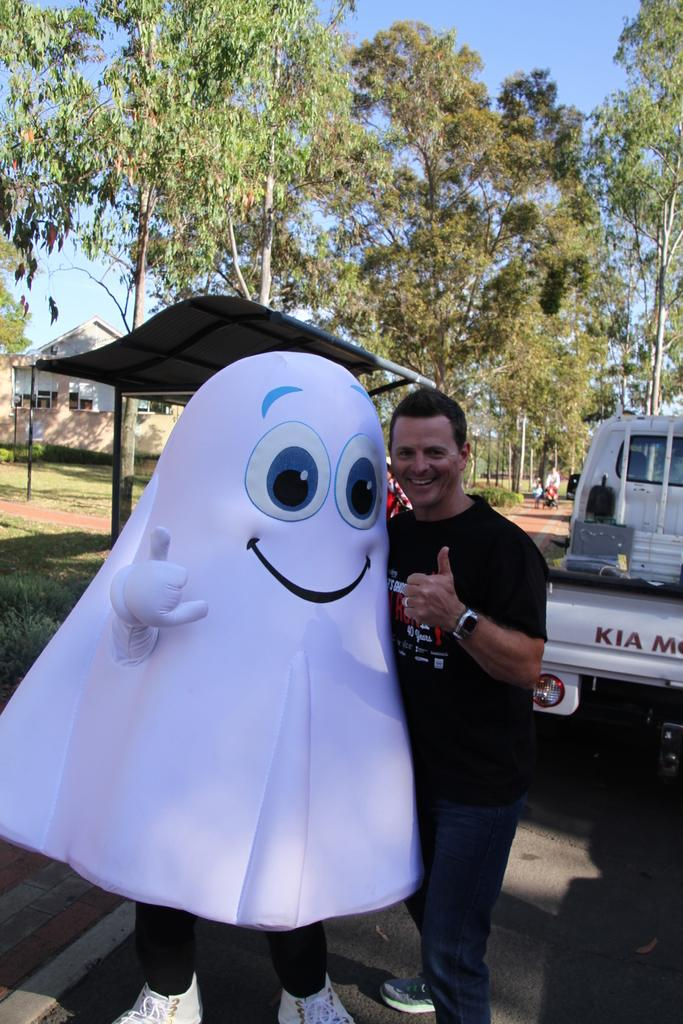What is the main subject in the center of the image? There is a man standing in the center of the image. Who or what is next to the man? There is a clown next to the man. What can be seen in the background of the image? There is a vehicle on the road, a shed, a building, trees, and the sky visible in the background. What type of stitch is being used to sew the oatmeal in the image? There is no oatmeal or stitching present in the image. What is the man and clown having for breakfast in the image? The image does not show any food or mention of breakfast. 